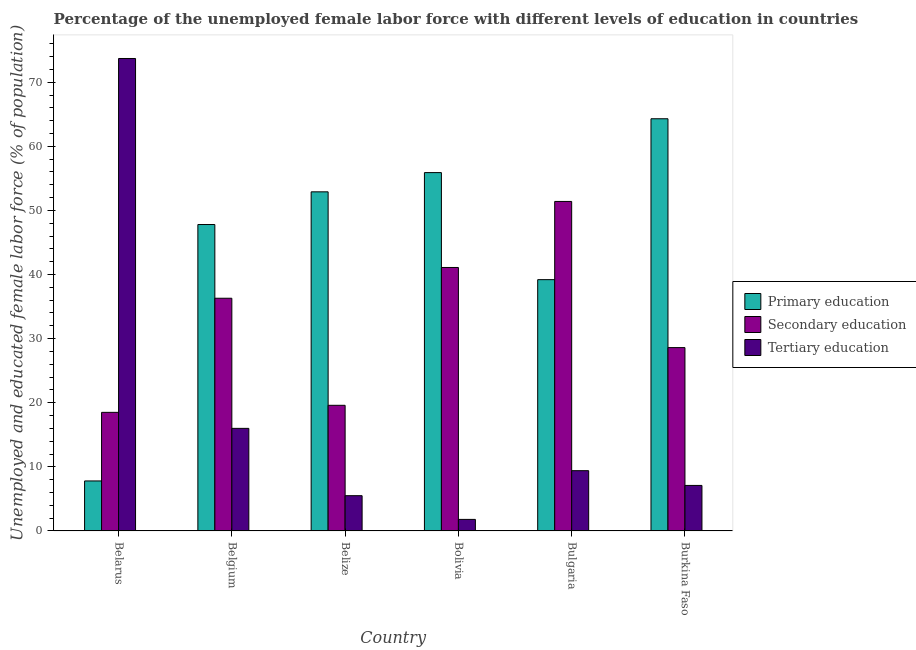How many different coloured bars are there?
Provide a short and direct response. 3. How many groups of bars are there?
Make the answer very short. 6. Are the number of bars per tick equal to the number of legend labels?
Your answer should be compact. Yes. How many bars are there on the 6th tick from the left?
Your answer should be very brief. 3. How many bars are there on the 2nd tick from the right?
Provide a short and direct response. 3. What is the label of the 2nd group of bars from the left?
Your answer should be compact. Belgium. In how many cases, is the number of bars for a given country not equal to the number of legend labels?
Give a very brief answer. 0. What is the percentage of female labor force who received secondary education in Bolivia?
Provide a short and direct response. 41.1. Across all countries, what is the maximum percentage of female labor force who received primary education?
Provide a short and direct response. 64.3. Across all countries, what is the minimum percentage of female labor force who received primary education?
Your response must be concise. 7.8. In which country was the percentage of female labor force who received primary education maximum?
Provide a succinct answer. Burkina Faso. In which country was the percentage of female labor force who received primary education minimum?
Provide a short and direct response. Belarus. What is the total percentage of female labor force who received primary education in the graph?
Offer a terse response. 267.9. What is the difference between the percentage of female labor force who received primary education in Belgium and that in Bolivia?
Your response must be concise. -8.1. What is the difference between the percentage of female labor force who received primary education in Bolivia and the percentage of female labor force who received tertiary education in Belize?
Give a very brief answer. 50.4. What is the average percentage of female labor force who received primary education per country?
Keep it short and to the point. 44.65. What is the difference between the percentage of female labor force who received secondary education and percentage of female labor force who received tertiary education in Bulgaria?
Offer a very short reply. 42. What is the ratio of the percentage of female labor force who received secondary education in Belarus to that in Bolivia?
Provide a succinct answer. 0.45. Is the percentage of female labor force who received secondary education in Belarus less than that in Burkina Faso?
Give a very brief answer. Yes. Is the difference between the percentage of female labor force who received primary education in Belarus and Bolivia greater than the difference between the percentage of female labor force who received secondary education in Belarus and Bolivia?
Keep it short and to the point. No. What is the difference between the highest and the second highest percentage of female labor force who received secondary education?
Provide a succinct answer. 10.3. What is the difference between the highest and the lowest percentage of female labor force who received secondary education?
Your response must be concise. 32.9. Is the sum of the percentage of female labor force who received tertiary education in Belarus and Belgium greater than the maximum percentage of female labor force who received primary education across all countries?
Your response must be concise. Yes. What does the 3rd bar from the left in Bolivia represents?
Your answer should be compact. Tertiary education. What does the 2nd bar from the right in Belarus represents?
Your answer should be compact. Secondary education. Is it the case that in every country, the sum of the percentage of female labor force who received primary education and percentage of female labor force who received secondary education is greater than the percentage of female labor force who received tertiary education?
Your answer should be very brief. No. What is the difference between two consecutive major ticks on the Y-axis?
Offer a terse response. 10. Are the values on the major ticks of Y-axis written in scientific E-notation?
Keep it short and to the point. No. Does the graph contain any zero values?
Your answer should be very brief. No. Does the graph contain grids?
Make the answer very short. No. Where does the legend appear in the graph?
Your answer should be very brief. Center right. How are the legend labels stacked?
Your answer should be compact. Vertical. What is the title of the graph?
Make the answer very short. Percentage of the unemployed female labor force with different levels of education in countries. Does "Slovak Republic" appear as one of the legend labels in the graph?
Make the answer very short. No. What is the label or title of the X-axis?
Offer a very short reply. Country. What is the label or title of the Y-axis?
Provide a short and direct response. Unemployed and educated female labor force (% of population). What is the Unemployed and educated female labor force (% of population) in Primary education in Belarus?
Give a very brief answer. 7.8. What is the Unemployed and educated female labor force (% of population) in Tertiary education in Belarus?
Provide a short and direct response. 73.7. What is the Unemployed and educated female labor force (% of population) in Primary education in Belgium?
Provide a succinct answer. 47.8. What is the Unemployed and educated female labor force (% of population) in Secondary education in Belgium?
Make the answer very short. 36.3. What is the Unemployed and educated female labor force (% of population) in Primary education in Belize?
Make the answer very short. 52.9. What is the Unemployed and educated female labor force (% of population) of Secondary education in Belize?
Offer a very short reply. 19.6. What is the Unemployed and educated female labor force (% of population) of Primary education in Bolivia?
Keep it short and to the point. 55.9. What is the Unemployed and educated female labor force (% of population) in Secondary education in Bolivia?
Give a very brief answer. 41.1. What is the Unemployed and educated female labor force (% of population) in Tertiary education in Bolivia?
Keep it short and to the point. 1.8. What is the Unemployed and educated female labor force (% of population) of Primary education in Bulgaria?
Offer a very short reply. 39.2. What is the Unemployed and educated female labor force (% of population) in Secondary education in Bulgaria?
Provide a succinct answer. 51.4. What is the Unemployed and educated female labor force (% of population) of Tertiary education in Bulgaria?
Keep it short and to the point. 9.4. What is the Unemployed and educated female labor force (% of population) in Primary education in Burkina Faso?
Provide a succinct answer. 64.3. What is the Unemployed and educated female labor force (% of population) of Secondary education in Burkina Faso?
Make the answer very short. 28.6. What is the Unemployed and educated female labor force (% of population) of Tertiary education in Burkina Faso?
Your answer should be very brief. 7.1. Across all countries, what is the maximum Unemployed and educated female labor force (% of population) in Primary education?
Give a very brief answer. 64.3. Across all countries, what is the maximum Unemployed and educated female labor force (% of population) of Secondary education?
Your response must be concise. 51.4. Across all countries, what is the maximum Unemployed and educated female labor force (% of population) of Tertiary education?
Offer a terse response. 73.7. Across all countries, what is the minimum Unemployed and educated female labor force (% of population) in Primary education?
Make the answer very short. 7.8. Across all countries, what is the minimum Unemployed and educated female labor force (% of population) of Secondary education?
Your answer should be very brief. 18.5. Across all countries, what is the minimum Unemployed and educated female labor force (% of population) in Tertiary education?
Offer a very short reply. 1.8. What is the total Unemployed and educated female labor force (% of population) of Primary education in the graph?
Make the answer very short. 267.9. What is the total Unemployed and educated female labor force (% of population) in Secondary education in the graph?
Your answer should be very brief. 195.5. What is the total Unemployed and educated female labor force (% of population) in Tertiary education in the graph?
Your response must be concise. 113.5. What is the difference between the Unemployed and educated female labor force (% of population) of Primary education in Belarus and that in Belgium?
Give a very brief answer. -40. What is the difference between the Unemployed and educated female labor force (% of population) of Secondary education in Belarus and that in Belgium?
Give a very brief answer. -17.8. What is the difference between the Unemployed and educated female labor force (% of population) in Tertiary education in Belarus and that in Belgium?
Your answer should be compact. 57.7. What is the difference between the Unemployed and educated female labor force (% of population) in Primary education in Belarus and that in Belize?
Provide a short and direct response. -45.1. What is the difference between the Unemployed and educated female labor force (% of population) of Secondary education in Belarus and that in Belize?
Your answer should be very brief. -1.1. What is the difference between the Unemployed and educated female labor force (% of population) in Tertiary education in Belarus and that in Belize?
Give a very brief answer. 68.2. What is the difference between the Unemployed and educated female labor force (% of population) in Primary education in Belarus and that in Bolivia?
Offer a terse response. -48.1. What is the difference between the Unemployed and educated female labor force (% of population) in Secondary education in Belarus and that in Bolivia?
Your answer should be compact. -22.6. What is the difference between the Unemployed and educated female labor force (% of population) of Tertiary education in Belarus and that in Bolivia?
Ensure brevity in your answer.  71.9. What is the difference between the Unemployed and educated female labor force (% of population) of Primary education in Belarus and that in Bulgaria?
Provide a succinct answer. -31.4. What is the difference between the Unemployed and educated female labor force (% of population) of Secondary education in Belarus and that in Bulgaria?
Give a very brief answer. -32.9. What is the difference between the Unemployed and educated female labor force (% of population) of Tertiary education in Belarus and that in Bulgaria?
Your answer should be very brief. 64.3. What is the difference between the Unemployed and educated female labor force (% of population) of Primary education in Belarus and that in Burkina Faso?
Your answer should be compact. -56.5. What is the difference between the Unemployed and educated female labor force (% of population) in Tertiary education in Belarus and that in Burkina Faso?
Keep it short and to the point. 66.6. What is the difference between the Unemployed and educated female labor force (% of population) in Secondary education in Belgium and that in Belize?
Provide a succinct answer. 16.7. What is the difference between the Unemployed and educated female labor force (% of population) of Secondary education in Belgium and that in Bolivia?
Make the answer very short. -4.8. What is the difference between the Unemployed and educated female labor force (% of population) in Primary education in Belgium and that in Bulgaria?
Your response must be concise. 8.6. What is the difference between the Unemployed and educated female labor force (% of population) of Secondary education in Belgium and that in Bulgaria?
Ensure brevity in your answer.  -15.1. What is the difference between the Unemployed and educated female labor force (% of population) of Primary education in Belgium and that in Burkina Faso?
Keep it short and to the point. -16.5. What is the difference between the Unemployed and educated female labor force (% of population) in Tertiary education in Belgium and that in Burkina Faso?
Ensure brevity in your answer.  8.9. What is the difference between the Unemployed and educated female labor force (% of population) of Primary education in Belize and that in Bolivia?
Your answer should be very brief. -3. What is the difference between the Unemployed and educated female labor force (% of population) in Secondary education in Belize and that in Bolivia?
Your response must be concise. -21.5. What is the difference between the Unemployed and educated female labor force (% of population) in Secondary education in Belize and that in Bulgaria?
Offer a very short reply. -31.8. What is the difference between the Unemployed and educated female labor force (% of population) of Tertiary education in Belize and that in Bulgaria?
Offer a terse response. -3.9. What is the difference between the Unemployed and educated female labor force (% of population) in Primary education in Belize and that in Burkina Faso?
Ensure brevity in your answer.  -11.4. What is the difference between the Unemployed and educated female labor force (% of population) of Tertiary education in Bolivia and that in Bulgaria?
Give a very brief answer. -7.6. What is the difference between the Unemployed and educated female labor force (% of population) of Tertiary education in Bolivia and that in Burkina Faso?
Provide a short and direct response. -5.3. What is the difference between the Unemployed and educated female labor force (% of population) of Primary education in Bulgaria and that in Burkina Faso?
Keep it short and to the point. -25.1. What is the difference between the Unemployed and educated female labor force (% of population) in Secondary education in Bulgaria and that in Burkina Faso?
Your answer should be very brief. 22.8. What is the difference between the Unemployed and educated female labor force (% of population) of Tertiary education in Bulgaria and that in Burkina Faso?
Offer a very short reply. 2.3. What is the difference between the Unemployed and educated female labor force (% of population) in Primary education in Belarus and the Unemployed and educated female labor force (% of population) in Secondary education in Belgium?
Give a very brief answer. -28.5. What is the difference between the Unemployed and educated female labor force (% of population) of Primary education in Belarus and the Unemployed and educated female labor force (% of population) of Secondary education in Belize?
Offer a very short reply. -11.8. What is the difference between the Unemployed and educated female labor force (% of population) of Primary education in Belarus and the Unemployed and educated female labor force (% of population) of Tertiary education in Belize?
Offer a terse response. 2.3. What is the difference between the Unemployed and educated female labor force (% of population) of Secondary education in Belarus and the Unemployed and educated female labor force (% of population) of Tertiary education in Belize?
Offer a very short reply. 13. What is the difference between the Unemployed and educated female labor force (% of population) in Primary education in Belarus and the Unemployed and educated female labor force (% of population) in Secondary education in Bolivia?
Provide a succinct answer. -33.3. What is the difference between the Unemployed and educated female labor force (% of population) of Primary education in Belarus and the Unemployed and educated female labor force (% of population) of Tertiary education in Bolivia?
Give a very brief answer. 6. What is the difference between the Unemployed and educated female labor force (% of population) in Secondary education in Belarus and the Unemployed and educated female labor force (% of population) in Tertiary education in Bolivia?
Your response must be concise. 16.7. What is the difference between the Unemployed and educated female labor force (% of population) of Primary education in Belarus and the Unemployed and educated female labor force (% of population) of Secondary education in Bulgaria?
Offer a terse response. -43.6. What is the difference between the Unemployed and educated female labor force (% of population) of Secondary education in Belarus and the Unemployed and educated female labor force (% of population) of Tertiary education in Bulgaria?
Your answer should be very brief. 9.1. What is the difference between the Unemployed and educated female labor force (% of population) of Primary education in Belarus and the Unemployed and educated female labor force (% of population) of Secondary education in Burkina Faso?
Your answer should be very brief. -20.8. What is the difference between the Unemployed and educated female labor force (% of population) of Secondary education in Belarus and the Unemployed and educated female labor force (% of population) of Tertiary education in Burkina Faso?
Give a very brief answer. 11.4. What is the difference between the Unemployed and educated female labor force (% of population) of Primary education in Belgium and the Unemployed and educated female labor force (% of population) of Secondary education in Belize?
Provide a succinct answer. 28.2. What is the difference between the Unemployed and educated female labor force (% of population) of Primary education in Belgium and the Unemployed and educated female labor force (% of population) of Tertiary education in Belize?
Make the answer very short. 42.3. What is the difference between the Unemployed and educated female labor force (% of population) of Secondary education in Belgium and the Unemployed and educated female labor force (% of population) of Tertiary education in Belize?
Ensure brevity in your answer.  30.8. What is the difference between the Unemployed and educated female labor force (% of population) in Primary education in Belgium and the Unemployed and educated female labor force (% of population) in Secondary education in Bolivia?
Provide a succinct answer. 6.7. What is the difference between the Unemployed and educated female labor force (% of population) of Secondary education in Belgium and the Unemployed and educated female labor force (% of population) of Tertiary education in Bolivia?
Keep it short and to the point. 34.5. What is the difference between the Unemployed and educated female labor force (% of population) of Primary education in Belgium and the Unemployed and educated female labor force (% of population) of Tertiary education in Bulgaria?
Provide a succinct answer. 38.4. What is the difference between the Unemployed and educated female labor force (% of population) of Secondary education in Belgium and the Unemployed and educated female labor force (% of population) of Tertiary education in Bulgaria?
Give a very brief answer. 26.9. What is the difference between the Unemployed and educated female labor force (% of population) of Primary education in Belgium and the Unemployed and educated female labor force (% of population) of Tertiary education in Burkina Faso?
Provide a short and direct response. 40.7. What is the difference between the Unemployed and educated female labor force (% of population) in Secondary education in Belgium and the Unemployed and educated female labor force (% of population) in Tertiary education in Burkina Faso?
Keep it short and to the point. 29.2. What is the difference between the Unemployed and educated female labor force (% of population) in Primary education in Belize and the Unemployed and educated female labor force (% of population) in Secondary education in Bolivia?
Offer a terse response. 11.8. What is the difference between the Unemployed and educated female labor force (% of population) of Primary education in Belize and the Unemployed and educated female labor force (% of population) of Tertiary education in Bolivia?
Keep it short and to the point. 51.1. What is the difference between the Unemployed and educated female labor force (% of population) in Primary education in Belize and the Unemployed and educated female labor force (% of population) in Secondary education in Bulgaria?
Ensure brevity in your answer.  1.5. What is the difference between the Unemployed and educated female labor force (% of population) in Primary education in Belize and the Unemployed and educated female labor force (% of population) in Tertiary education in Bulgaria?
Give a very brief answer. 43.5. What is the difference between the Unemployed and educated female labor force (% of population) of Primary education in Belize and the Unemployed and educated female labor force (% of population) of Secondary education in Burkina Faso?
Keep it short and to the point. 24.3. What is the difference between the Unemployed and educated female labor force (% of population) of Primary education in Belize and the Unemployed and educated female labor force (% of population) of Tertiary education in Burkina Faso?
Provide a short and direct response. 45.8. What is the difference between the Unemployed and educated female labor force (% of population) of Primary education in Bolivia and the Unemployed and educated female labor force (% of population) of Tertiary education in Bulgaria?
Make the answer very short. 46.5. What is the difference between the Unemployed and educated female labor force (% of population) of Secondary education in Bolivia and the Unemployed and educated female labor force (% of population) of Tertiary education in Bulgaria?
Offer a very short reply. 31.7. What is the difference between the Unemployed and educated female labor force (% of population) in Primary education in Bolivia and the Unemployed and educated female labor force (% of population) in Secondary education in Burkina Faso?
Offer a terse response. 27.3. What is the difference between the Unemployed and educated female labor force (% of population) in Primary education in Bolivia and the Unemployed and educated female labor force (% of population) in Tertiary education in Burkina Faso?
Make the answer very short. 48.8. What is the difference between the Unemployed and educated female labor force (% of population) of Primary education in Bulgaria and the Unemployed and educated female labor force (% of population) of Secondary education in Burkina Faso?
Your answer should be very brief. 10.6. What is the difference between the Unemployed and educated female labor force (% of population) in Primary education in Bulgaria and the Unemployed and educated female labor force (% of population) in Tertiary education in Burkina Faso?
Give a very brief answer. 32.1. What is the difference between the Unemployed and educated female labor force (% of population) in Secondary education in Bulgaria and the Unemployed and educated female labor force (% of population) in Tertiary education in Burkina Faso?
Give a very brief answer. 44.3. What is the average Unemployed and educated female labor force (% of population) in Primary education per country?
Your response must be concise. 44.65. What is the average Unemployed and educated female labor force (% of population) of Secondary education per country?
Your response must be concise. 32.58. What is the average Unemployed and educated female labor force (% of population) in Tertiary education per country?
Your answer should be very brief. 18.92. What is the difference between the Unemployed and educated female labor force (% of population) in Primary education and Unemployed and educated female labor force (% of population) in Tertiary education in Belarus?
Make the answer very short. -65.9. What is the difference between the Unemployed and educated female labor force (% of population) of Secondary education and Unemployed and educated female labor force (% of population) of Tertiary education in Belarus?
Provide a short and direct response. -55.2. What is the difference between the Unemployed and educated female labor force (% of population) in Primary education and Unemployed and educated female labor force (% of population) in Tertiary education in Belgium?
Provide a succinct answer. 31.8. What is the difference between the Unemployed and educated female labor force (% of population) of Secondary education and Unemployed and educated female labor force (% of population) of Tertiary education in Belgium?
Your answer should be very brief. 20.3. What is the difference between the Unemployed and educated female labor force (% of population) of Primary education and Unemployed and educated female labor force (% of population) of Secondary education in Belize?
Ensure brevity in your answer.  33.3. What is the difference between the Unemployed and educated female labor force (% of population) of Primary education and Unemployed and educated female labor force (% of population) of Tertiary education in Belize?
Your response must be concise. 47.4. What is the difference between the Unemployed and educated female labor force (% of population) in Primary education and Unemployed and educated female labor force (% of population) in Tertiary education in Bolivia?
Ensure brevity in your answer.  54.1. What is the difference between the Unemployed and educated female labor force (% of population) of Secondary education and Unemployed and educated female labor force (% of population) of Tertiary education in Bolivia?
Provide a short and direct response. 39.3. What is the difference between the Unemployed and educated female labor force (% of population) of Primary education and Unemployed and educated female labor force (% of population) of Tertiary education in Bulgaria?
Provide a succinct answer. 29.8. What is the difference between the Unemployed and educated female labor force (% of population) in Primary education and Unemployed and educated female labor force (% of population) in Secondary education in Burkina Faso?
Your response must be concise. 35.7. What is the difference between the Unemployed and educated female labor force (% of population) of Primary education and Unemployed and educated female labor force (% of population) of Tertiary education in Burkina Faso?
Offer a terse response. 57.2. What is the ratio of the Unemployed and educated female labor force (% of population) in Primary education in Belarus to that in Belgium?
Your answer should be compact. 0.16. What is the ratio of the Unemployed and educated female labor force (% of population) of Secondary education in Belarus to that in Belgium?
Give a very brief answer. 0.51. What is the ratio of the Unemployed and educated female labor force (% of population) of Tertiary education in Belarus to that in Belgium?
Give a very brief answer. 4.61. What is the ratio of the Unemployed and educated female labor force (% of population) in Primary education in Belarus to that in Belize?
Keep it short and to the point. 0.15. What is the ratio of the Unemployed and educated female labor force (% of population) in Secondary education in Belarus to that in Belize?
Offer a very short reply. 0.94. What is the ratio of the Unemployed and educated female labor force (% of population) of Primary education in Belarus to that in Bolivia?
Ensure brevity in your answer.  0.14. What is the ratio of the Unemployed and educated female labor force (% of population) of Secondary education in Belarus to that in Bolivia?
Provide a short and direct response. 0.45. What is the ratio of the Unemployed and educated female labor force (% of population) in Tertiary education in Belarus to that in Bolivia?
Make the answer very short. 40.94. What is the ratio of the Unemployed and educated female labor force (% of population) of Primary education in Belarus to that in Bulgaria?
Provide a short and direct response. 0.2. What is the ratio of the Unemployed and educated female labor force (% of population) of Secondary education in Belarus to that in Bulgaria?
Provide a succinct answer. 0.36. What is the ratio of the Unemployed and educated female labor force (% of population) in Tertiary education in Belarus to that in Bulgaria?
Offer a very short reply. 7.84. What is the ratio of the Unemployed and educated female labor force (% of population) in Primary education in Belarus to that in Burkina Faso?
Make the answer very short. 0.12. What is the ratio of the Unemployed and educated female labor force (% of population) of Secondary education in Belarus to that in Burkina Faso?
Your answer should be very brief. 0.65. What is the ratio of the Unemployed and educated female labor force (% of population) in Tertiary education in Belarus to that in Burkina Faso?
Provide a succinct answer. 10.38. What is the ratio of the Unemployed and educated female labor force (% of population) of Primary education in Belgium to that in Belize?
Make the answer very short. 0.9. What is the ratio of the Unemployed and educated female labor force (% of population) in Secondary education in Belgium to that in Belize?
Keep it short and to the point. 1.85. What is the ratio of the Unemployed and educated female labor force (% of population) in Tertiary education in Belgium to that in Belize?
Keep it short and to the point. 2.91. What is the ratio of the Unemployed and educated female labor force (% of population) in Primary education in Belgium to that in Bolivia?
Keep it short and to the point. 0.86. What is the ratio of the Unemployed and educated female labor force (% of population) of Secondary education in Belgium to that in Bolivia?
Provide a succinct answer. 0.88. What is the ratio of the Unemployed and educated female labor force (% of population) in Tertiary education in Belgium to that in Bolivia?
Make the answer very short. 8.89. What is the ratio of the Unemployed and educated female labor force (% of population) in Primary education in Belgium to that in Bulgaria?
Provide a succinct answer. 1.22. What is the ratio of the Unemployed and educated female labor force (% of population) in Secondary education in Belgium to that in Bulgaria?
Give a very brief answer. 0.71. What is the ratio of the Unemployed and educated female labor force (% of population) of Tertiary education in Belgium to that in Bulgaria?
Ensure brevity in your answer.  1.7. What is the ratio of the Unemployed and educated female labor force (% of population) of Primary education in Belgium to that in Burkina Faso?
Keep it short and to the point. 0.74. What is the ratio of the Unemployed and educated female labor force (% of population) in Secondary education in Belgium to that in Burkina Faso?
Your response must be concise. 1.27. What is the ratio of the Unemployed and educated female labor force (% of population) of Tertiary education in Belgium to that in Burkina Faso?
Offer a very short reply. 2.25. What is the ratio of the Unemployed and educated female labor force (% of population) in Primary education in Belize to that in Bolivia?
Provide a succinct answer. 0.95. What is the ratio of the Unemployed and educated female labor force (% of population) in Secondary education in Belize to that in Bolivia?
Offer a very short reply. 0.48. What is the ratio of the Unemployed and educated female labor force (% of population) in Tertiary education in Belize to that in Bolivia?
Your answer should be compact. 3.06. What is the ratio of the Unemployed and educated female labor force (% of population) of Primary education in Belize to that in Bulgaria?
Ensure brevity in your answer.  1.35. What is the ratio of the Unemployed and educated female labor force (% of population) of Secondary education in Belize to that in Bulgaria?
Ensure brevity in your answer.  0.38. What is the ratio of the Unemployed and educated female labor force (% of population) in Tertiary education in Belize to that in Bulgaria?
Give a very brief answer. 0.59. What is the ratio of the Unemployed and educated female labor force (% of population) of Primary education in Belize to that in Burkina Faso?
Offer a terse response. 0.82. What is the ratio of the Unemployed and educated female labor force (% of population) in Secondary education in Belize to that in Burkina Faso?
Ensure brevity in your answer.  0.69. What is the ratio of the Unemployed and educated female labor force (% of population) in Tertiary education in Belize to that in Burkina Faso?
Keep it short and to the point. 0.77. What is the ratio of the Unemployed and educated female labor force (% of population) of Primary education in Bolivia to that in Bulgaria?
Your answer should be very brief. 1.43. What is the ratio of the Unemployed and educated female labor force (% of population) of Secondary education in Bolivia to that in Bulgaria?
Keep it short and to the point. 0.8. What is the ratio of the Unemployed and educated female labor force (% of population) of Tertiary education in Bolivia to that in Bulgaria?
Offer a very short reply. 0.19. What is the ratio of the Unemployed and educated female labor force (% of population) in Primary education in Bolivia to that in Burkina Faso?
Offer a terse response. 0.87. What is the ratio of the Unemployed and educated female labor force (% of population) in Secondary education in Bolivia to that in Burkina Faso?
Your response must be concise. 1.44. What is the ratio of the Unemployed and educated female labor force (% of population) in Tertiary education in Bolivia to that in Burkina Faso?
Offer a terse response. 0.25. What is the ratio of the Unemployed and educated female labor force (% of population) of Primary education in Bulgaria to that in Burkina Faso?
Ensure brevity in your answer.  0.61. What is the ratio of the Unemployed and educated female labor force (% of population) of Secondary education in Bulgaria to that in Burkina Faso?
Your answer should be compact. 1.8. What is the ratio of the Unemployed and educated female labor force (% of population) in Tertiary education in Bulgaria to that in Burkina Faso?
Provide a short and direct response. 1.32. What is the difference between the highest and the second highest Unemployed and educated female labor force (% of population) in Primary education?
Give a very brief answer. 8.4. What is the difference between the highest and the second highest Unemployed and educated female labor force (% of population) of Secondary education?
Provide a succinct answer. 10.3. What is the difference between the highest and the second highest Unemployed and educated female labor force (% of population) of Tertiary education?
Make the answer very short. 57.7. What is the difference between the highest and the lowest Unemployed and educated female labor force (% of population) of Primary education?
Provide a succinct answer. 56.5. What is the difference between the highest and the lowest Unemployed and educated female labor force (% of population) of Secondary education?
Ensure brevity in your answer.  32.9. What is the difference between the highest and the lowest Unemployed and educated female labor force (% of population) of Tertiary education?
Your answer should be very brief. 71.9. 